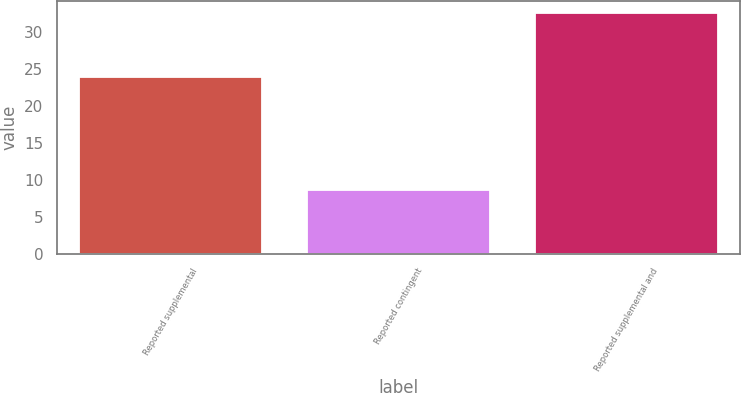<chart> <loc_0><loc_0><loc_500><loc_500><bar_chart><fcel>Reported supplemental<fcel>Reported contingent<fcel>Reported supplemental and<nl><fcel>23.9<fcel>8.6<fcel>32.5<nl></chart> 